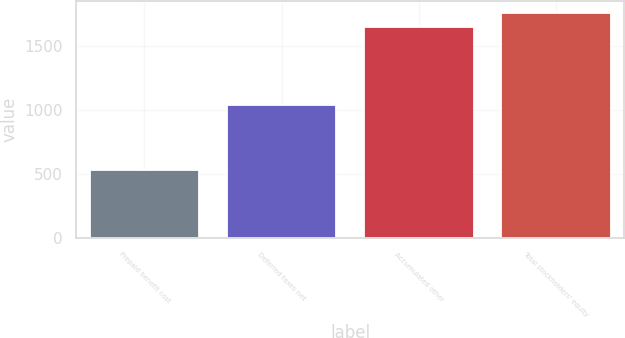Convert chart to OTSL. <chart><loc_0><loc_0><loc_500><loc_500><bar_chart><fcel>Prepaid benefit cost<fcel>Deferred taxes net<fcel>Accumulated other<fcel>Total stockholders' equity<nl><fcel>534<fcel>1034<fcel>1647<fcel>1758.3<nl></chart> 